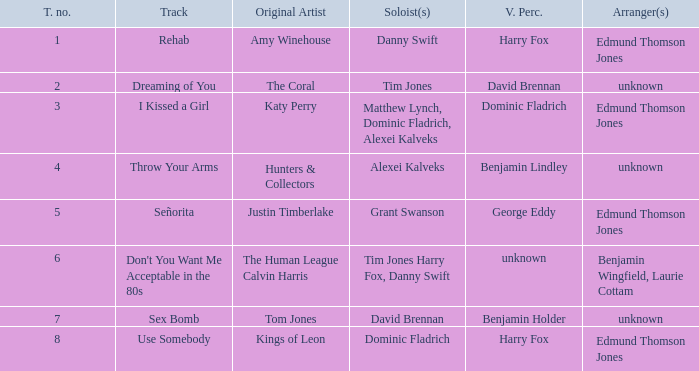Who is the original artist of "Use Somebody"? Kings of Leon. 